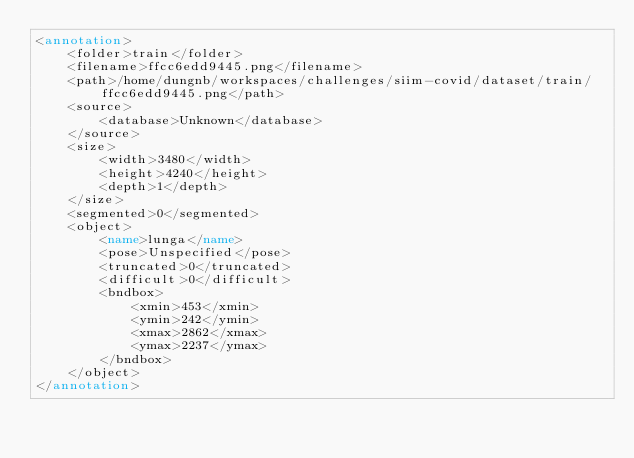Convert code to text. <code><loc_0><loc_0><loc_500><loc_500><_XML_><annotation>
	<folder>train</folder>
	<filename>ffcc6edd9445.png</filename>
	<path>/home/dungnb/workspaces/challenges/siim-covid/dataset/train/ffcc6edd9445.png</path>
	<source>
		<database>Unknown</database>
	</source>
	<size>
		<width>3480</width>
		<height>4240</height>
		<depth>1</depth>
	</size>
	<segmented>0</segmented>
	<object>
		<name>lunga</name>
		<pose>Unspecified</pose>
		<truncated>0</truncated>
		<difficult>0</difficult>
		<bndbox>
			<xmin>453</xmin>
			<ymin>242</ymin>
			<xmax>2862</xmax>
			<ymax>2237</ymax>
		</bndbox>
	</object>
</annotation>
</code> 